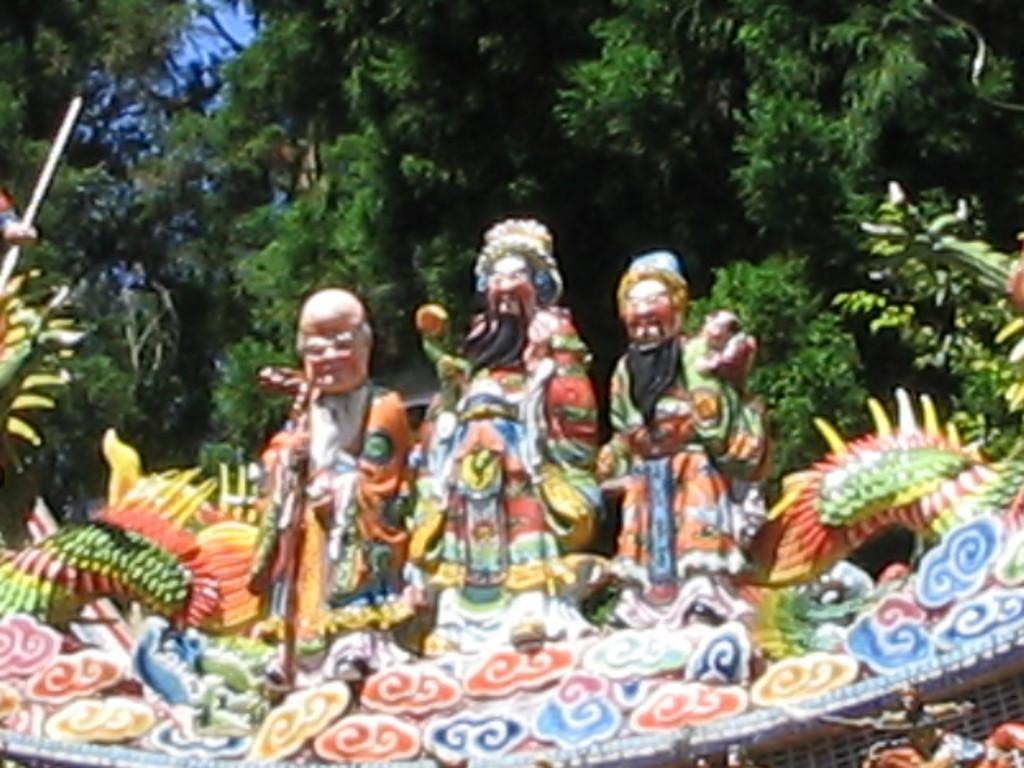What type of objects can be seen in the image? There are statues in the image. What can be seen in the background of the image? There are trees and the sky visible in the background of the image. What type of snail can be seen crawling on the steel surface in the image? There is no snail or steel surface present in the image; it features statues and a background with trees and the sky. 